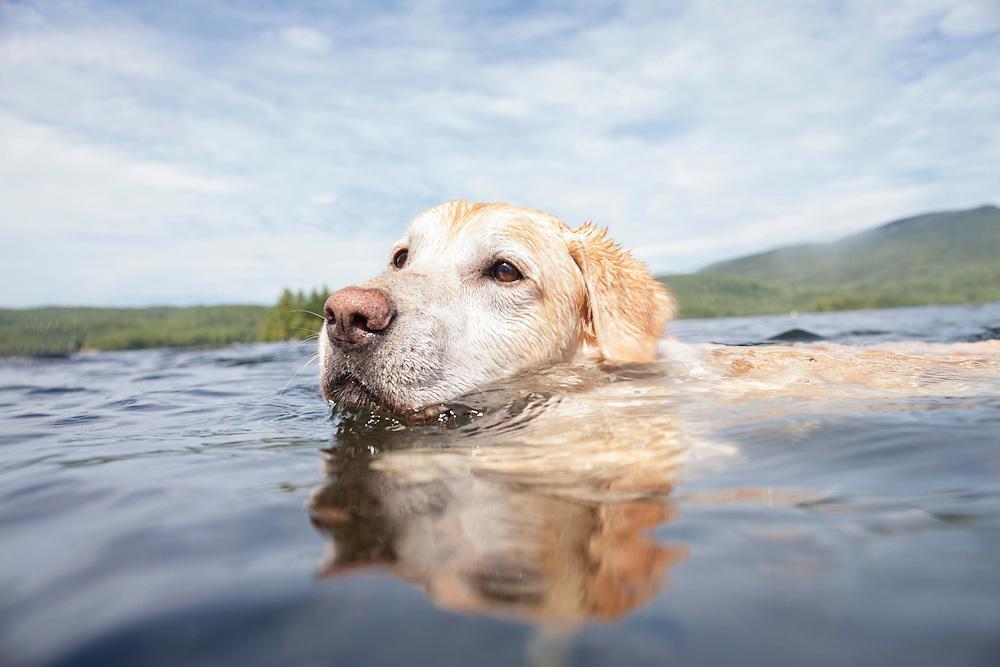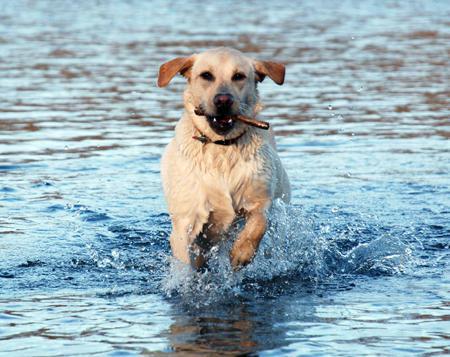The first image is the image on the left, the second image is the image on the right. Analyze the images presented: Is the assertion "The dog in the image on the left is swimming with a rod in its mouth." valid? Answer yes or no. No. 